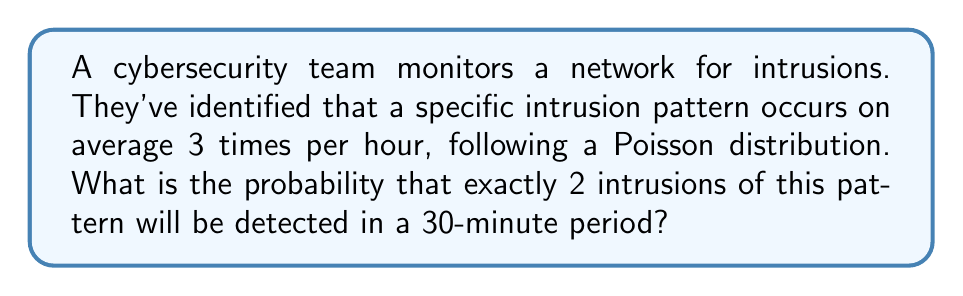Give your solution to this math problem. To solve this problem, we'll use the Poisson distribution formula:

$$P(X = k) = \frac{e^{-\lambda} \lambda^k}{k!}$$

Where:
$\lambda$ = average number of events in the given time interval
$k$ = number of events we're calculating the probability for
$e$ = Euler's number (approximately 2.71828)

Step 1: Calculate $\lambda$ for a 30-minute period
Given: 3 intrusions per hour on average
For 30 minutes: $\lambda = 3 \times \frac{30}{60} = 1.5$

Step 2: Apply the Poisson distribution formula
$k = 2$ (we want exactly 2 intrusions)
$\lambda = 1.5$

$$P(X = 2) = \frac{e^{-1.5} (1.5)^2}{2!}$$

Step 3: Calculate the result
$$P(X = 2) = \frac{e^{-1.5} (2.25)}{2}$$
$$P(X = 2) = \frac{0.22313 \times 2.25}{2}$$
$$P(X = 2) = 0.2510$$

Therefore, the probability of detecting exactly 2 intrusions in a 30-minute period is approximately 0.2510 or 25.10%.
Answer: $0.2510$ or $25.10\%$ 